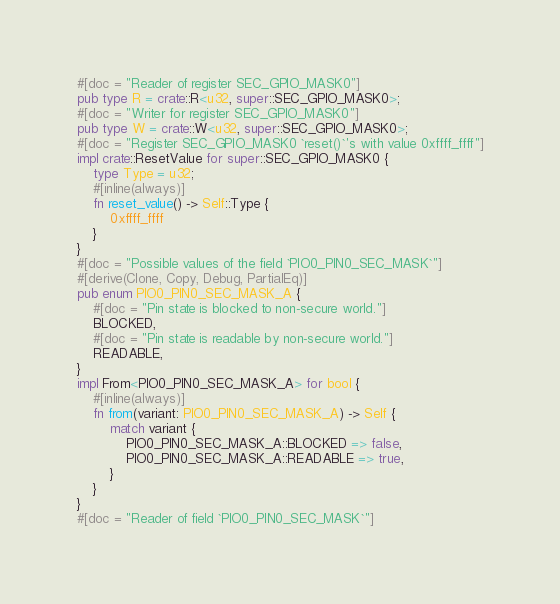Convert code to text. <code><loc_0><loc_0><loc_500><loc_500><_Rust_>#[doc = "Reader of register SEC_GPIO_MASK0"]
pub type R = crate::R<u32, super::SEC_GPIO_MASK0>;
#[doc = "Writer for register SEC_GPIO_MASK0"]
pub type W = crate::W<u32, super::SEC_GPIO_MASK0>;
#[doc = "Register SEC_GPIO_MASK0 `reset()`'s with value 0xffff_ffff"]
impl crate::ResetValue for super::SEC_GPIO_MASK0 {
    type Type = u32;
    #[inline(always)]
    fn reset_value() -> Self::Type {
        0xffff_ffff
    }
}
#[doc = "Possible values of the field `PIO0_PIN0_SEC_MASK`"]
#[derive(Clone, Copy, Debug, PartialEq)]
pub enum PIO0_PIN0_SEC_MASK_A {
    #[doc = "Pin state is blocked to non-secure world."]
    BLOCKED,
    #[doc = "Pin state is readable by non-secure world."]
    READABLE,
}
impl From<PIO0_PIN0_SEC_MASK_A> for bool {
    #[inline(always)]
    fn from(variant: PIO0_PIN0_SEC_MASK_A) -> Self {
        match variant {
            PIO0_PIN0_SEC_MASK_A::BLOCKED => false,
            PIO0_PIN0_SEC_MASK_A::READABLE => true,
        }
    }
}
#[doc = "Reader of field `PIO0_PIN0_SEC_MASK`"]</code> 